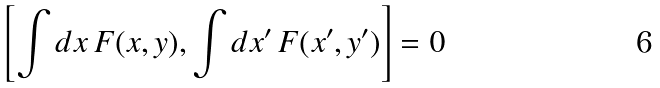Convert formula to latex. <formula><loc_0><loc_0><loc_500><loc_500>\left [ \int d x \, F ( x , y ) , \int d x ^ { \prime } \, F ( x ^ { \prime } , y ^ { \prime } ) \right ] = 0</formula> 